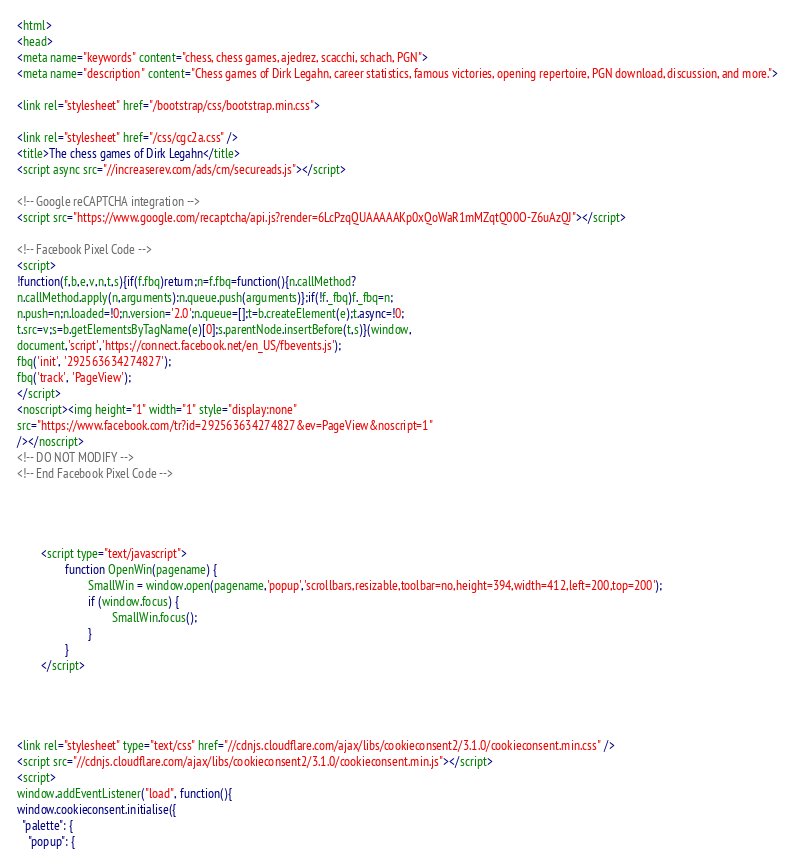<code> <loc_0><loc_0><loc_500><loc_500><_HTML_>
<html>
<head>
<meta name="keywords" content="chess, chess games, ajedrez, scacchi, schach, PGN">
<meta name="description" content="Chess games of Dirk Legahn, career statistics, famous victories, opening repertoire, PGN download, discussion, and more.">

<link rel="stylesheet" href="/bootstrap/css/bootstrap.min.css">

<link rel="stylesheet" href="/css/cgc2a.css" />
<title>The chess games of Dirk Legahn</title>
<script async src="//increaserev.com/ads/cm/secureads.js"></script>

<!-- Google reCAPTCHA integration -->
<script src="https://www.google.com/recaptcha/api.js?render=6LcPzqQUAAAAAKp0xQoWaR1mMZqtQ00O-Z6uAzQJ"></script>

<!-- Facebook Pixel Code -->
<script>
!function(f,b,e,v,n,t,s){if(f.fbq)return;n=f.fbq=function(){n.callMethod?
n.callMethod.apply(n,arguments):n.queue.push(arguments)};if(!f._fbq)f._fbq=n;
n.push=n;n.loaded=!0;n.version='2.0';n.queue=[];t=b.createElement(e);t.async=!0;
t.src=v;s=b.getElementsByTagName(e)[0];s.parentNode.insertBefore(t,s)}(window,
document,'script','https://connect.facebook.net/en_US/fbevents.js');
fbq('init', '292563634274827');
fbq('track', 'PageView');
</script>
<noscript><img height="1" width="1" style="display:none"
src="https://www.facebook.com/tr?id=292563634274827&ev=PageView&noscript=1"
/></noscript>
<!-- DO NOT MODIFY -->
<!-- End Facebook Pixel Code -->




		<script type="text/javascript">
                function OpenWin(pagename) {
                        SmallWin = window.open(pagename,'popup','scrollbars,resizable,toolbar=no,height=394,width=412,left=200,top=200');
                        if (window.focus) {
                                SmallWin.focus();
                        }
                }
		</script>




<link rel="stylesheet" type="text/css" href="//cdnjs.cloudflare.com/ajax/libs/cookieconsent2/3.1.0/cookieconsent.min.css" />
<script src="//cdnjs.cloudflare.com/ajax/libs/cookieconsent2/3.1.0/cookieconsent.min.js"></script>
<script>
window.addEventListener("load", function(){
window.cookieconsent.initialise({
  "palette": {
    "popup": {</code> 